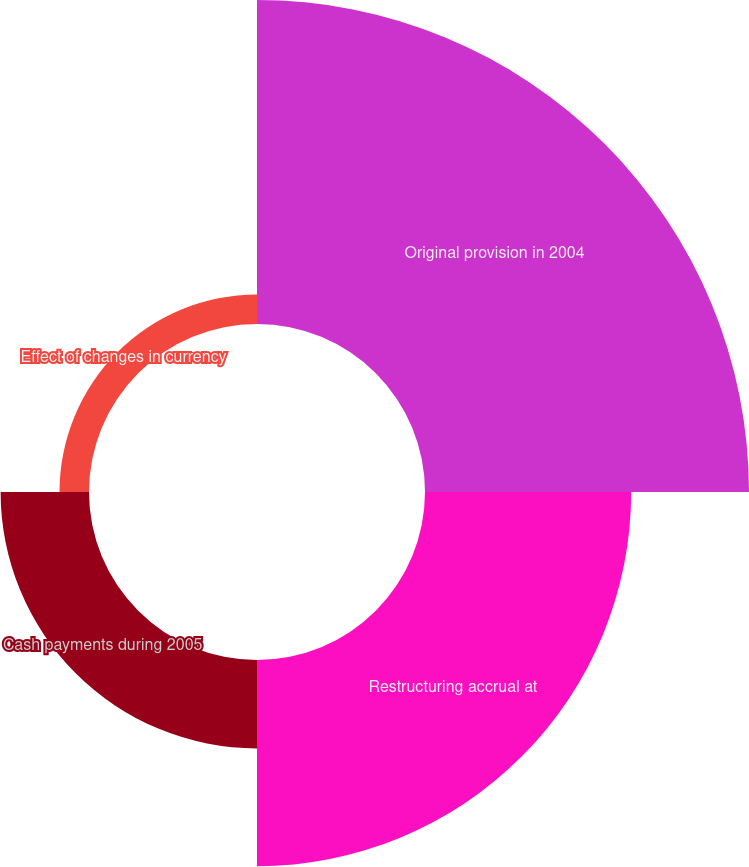Convert chart. <chart><loc_0><loc_0><loc_500><loc_500><pie_chart><fcel>Original provision in 2004<fcel>Restructuring accrual at<fcel>Cash payments during 2005<fcel>Effect of changes in currency<nl><fcel>50.0%<fcel>31.82%<fcel>13.64%<fcel>4.55%<nl></chart> 